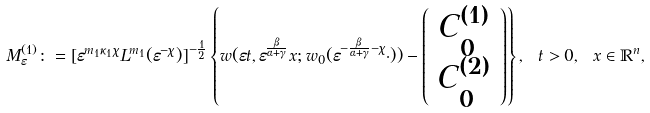<formula> <loc_0><loc_0><loc_500><loc_500>M ^ { ( 1 ) } _ { \varepsilon } \colon = [ \varepsilon ^ { m _ { 1 } \kappa _ { 1 } \chi } L ^ { m _ { 1 } } ( \varepsilon ^ { - \chi } ) ] ^ { - \frac { 1 } { 2 } } \left \{ w ( \varepsilon t , \varepsilon ^ { \frac { \beta } { \alpha + \gamma } } x ; w _ { 0 } ( \varepsilon ^ { - \frac { \beta } { \alpha + \gamma } - \chi } \cdot ) ) - \left ( \begin{array} { c c } C ^ { ( 1 ) } _ { 0 } \\ C ^ { ( 2 ) } _ { 0 } \end{array} \right ) \right \} , \ t > 0 , \ x \in \mathbb { R } ^ { n } ,</formula> 